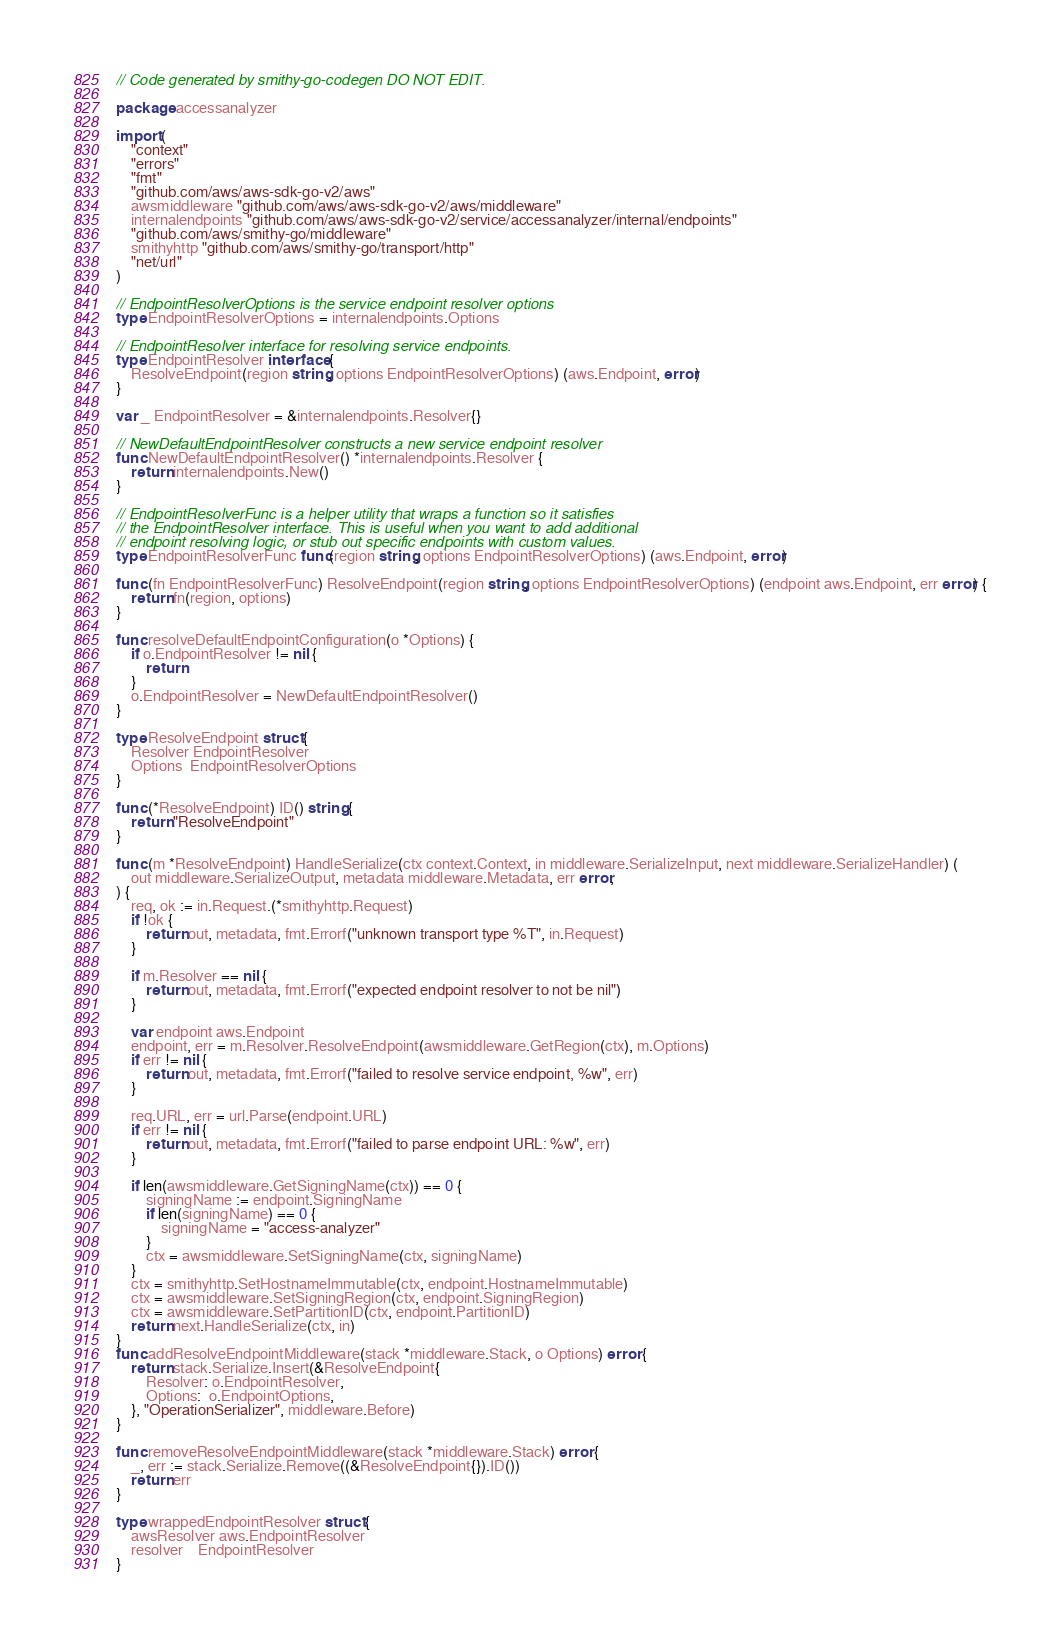<code> <loc_0><loc_0><loc_500><loc_500><_Go_>// Code generated by smithy-go-codegen DO NOT EDIT.

package accessanalyzer

import (
	"context"
	"errors"
	"fmt"
	"github.com/aws/aws-sdk-go-v2/aws"
	awsmiddleware "github.com/aws/aws-sdk-go-v2/aws/middleware"
	internalendpoints "github.com/aws/aws-sdk-go-v2/service/accessanalyzer/internal/endpoints"
	"github.com/aws/smithy-go/middleware"
	smithyhttp "github.com/aws/smithy-go/transport/http"
	"net/url"
)

// EndpointResolverOptions is the service endpoint resolver options
type EndpointResolverOptions = internalendpoints.Options

// EndpointResolver interface for resolving service endpoints.
type EndpointResolver interface {
	ResolveEndpoint(region string, options EndpointResolverOptions) (aws.Endpoint, error)
}

var _ EndpointResolver = &internalendpoints.Resolver{}

// NewDefaultEndpointResolver constructs a new service endpoint resolver
func NewDefaultEndpointResolver() *internalendpoints.Resolver {
	return internalendpoints.New()
}

// EndpointResolverFunc is a helper utility that wraps a function so it satisfies
// the EndpointResolver interface. This is useful when you want to add additional
// endpoint resolving logic, or stub out specific endpoints with custom values.
type EndpointResolverFunc func(region string, options EndpointResolverOptions) (aws.Endpoint, error)

func (fn EndpointResolverFunc) ResolveEndpoint(region string, options EndpointResolverOptions) (endpoint aws.Endpoint, err error) {
	return fn(region, options)
}

func resolveDefaultEndpointConfiguration(o *Options) {
	if o.EndpointResolver != nil {
		return
	}
	o.EndpointResolver = NewDefaultEndpointResolver()
}

type ResolveEndpoint struct {
	Resolver EndpointResolver
	Options  EndpointResolverOptions
}

func (*ResolveEndpoint) ID() string {
	return "ResolveEndpoint"
}

func (m *ResolveEndpoint) HandleSerialize(ctx context.Context, in middleware.SerializeInput, next middleware.SerializeHandler) (
	out middleware.SerializeOutput, metadata middleware.Metadata, err error,
) {
	req, ok := in.Request.(*smithyhttp.Request)
	if !ok {
		return out, metadata, fmt.Errorf("unknown transport type %T", in.Request)
	}

	if m.Resolver == nil {
		return out, metadata, fmt.Errorf("expected endpoint resolver to not be nil")
	}

	var endpoint aws.Endpoint
	endpoint, err = m.Resolver.ResolveEndpoint(awsmiddleware.GetRegion(ctx), m.Options)
	if err != nil {
		return out, metadata, fmt.Errorf("failed to resolve service endpoint, %w", err)
	}

	req.URL, err = url.Parse(endpoint.URL)
	if err != nil {
		return out, metadata, fmt.Errorf("failed to parse endpoint URL: %w", err)
	}

	if len(awsmiddleware.GetSigningName(ctx)) == 0 {
		signingName := endpoint.SigningName
		if len(signingName) == 0 {
			signingName = "access-analyzer"
		}
		ctx = awsmiddleware.SetSigningName(ctx, signingName)
	}
	ctx = smithyhttp.SetHostnameImmutable(ctx, endpoint.HostnameImmutable)
	ctx = awsmiddleware.SetSigningRegion(ctx, endpoint.SigningRegion)
	ctx = awsmiddleware.SetPartitionID(ctx, endpoint.PartitionID)
	return next.HandleSerialize(ctx, in)
}
func addResolveEndpointMiddleware(stack *middleware.Stack, o Options) error {
	return stack.Serialize.Insert(&ResolveEndpoint{
		Resolver: o.EndpointResolver,
		Options:  o.EndpointOptions,
	}, "OperationSerializer", middleware.Before)
}

func removeResolveEndpointMiddleware(stack *middleware.Stack) error {
	_, err := stack.Serialize.Remove((&ResolveEndpoint{}).ID())
	return err
}

type wrappedEndpointResolver struct {
	awsResolver aws.EndpointResolver
	resolver    EndpointResolver
}
</code> 